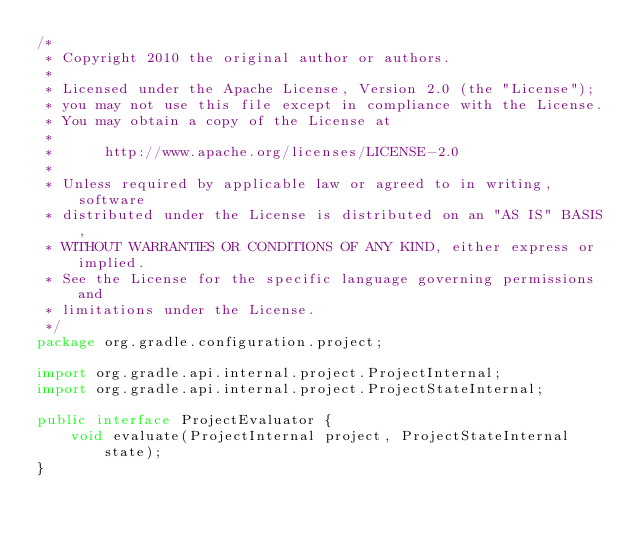<code> <loc_0><loc_0><loc_500><loc_500><_Java_>/*
 * Copyright 2010 the original author or authors.
 *
 * Licensed under the Apache License, Version 2.0 (the "License");
 * you may not use this file except in compliance with the License.
 * You may obtain a copy of the License at
 *
 *      http://www.apache.org/licenses/LICENSE-2.0
 *
 * Unless required by applicable law or agreed to in writing, software
 * distributed under the License is distributed on an "AS IS" BASIS,
 * WITHOUT WARRANTIES OR CONDITIONS OF ANY KIND, either express or implied.
 * See the License for the specific language governing permissions and
 * limitations under the License.
 */
package org.gradle.configuration.project;

import org.gradle.api.internal.project.ProjectInternal;
import org.gradle.api.internal.project.ProjectStateInternal;

public interface ProjectEvaluator {
    void evaluate(ProjectInternal project, ProjectStateInternal state);
}
</code> 